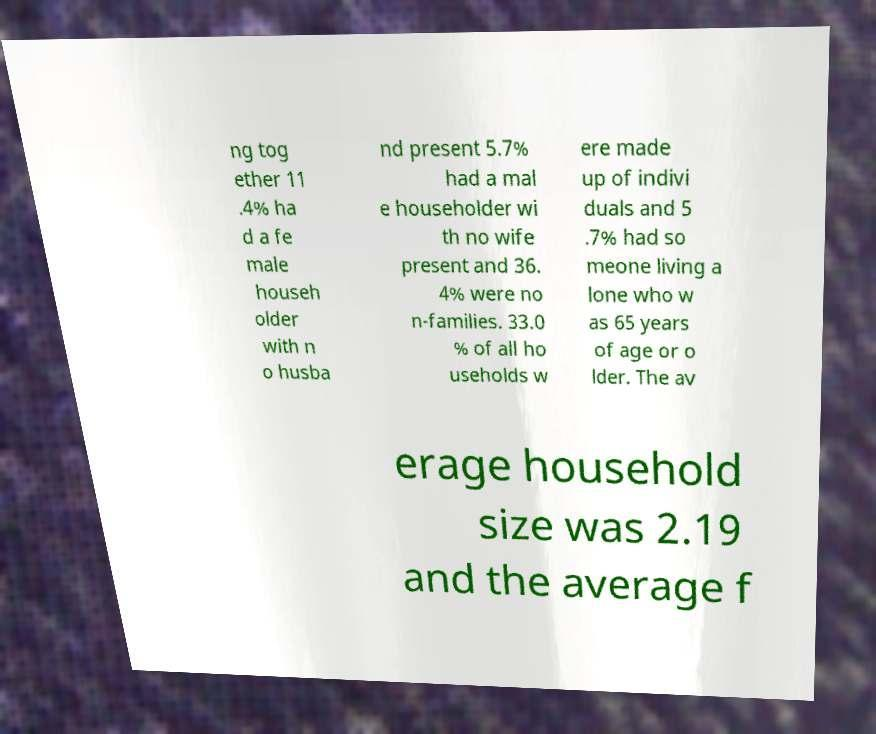Please identify and transcribe the text found in this image. ng tog ether 11 .4% ha d a fe male househ older with n o husba nd present 5.7% had a mal e householder wi th no wife present and 36. 4% were no n-families. 33.0 % of all ho useholds w ere made up of indivi duals and 5 .7% had so meone living a lone who w as 65 years of age or o lder. The av erage household size was 2.19 and the average f 